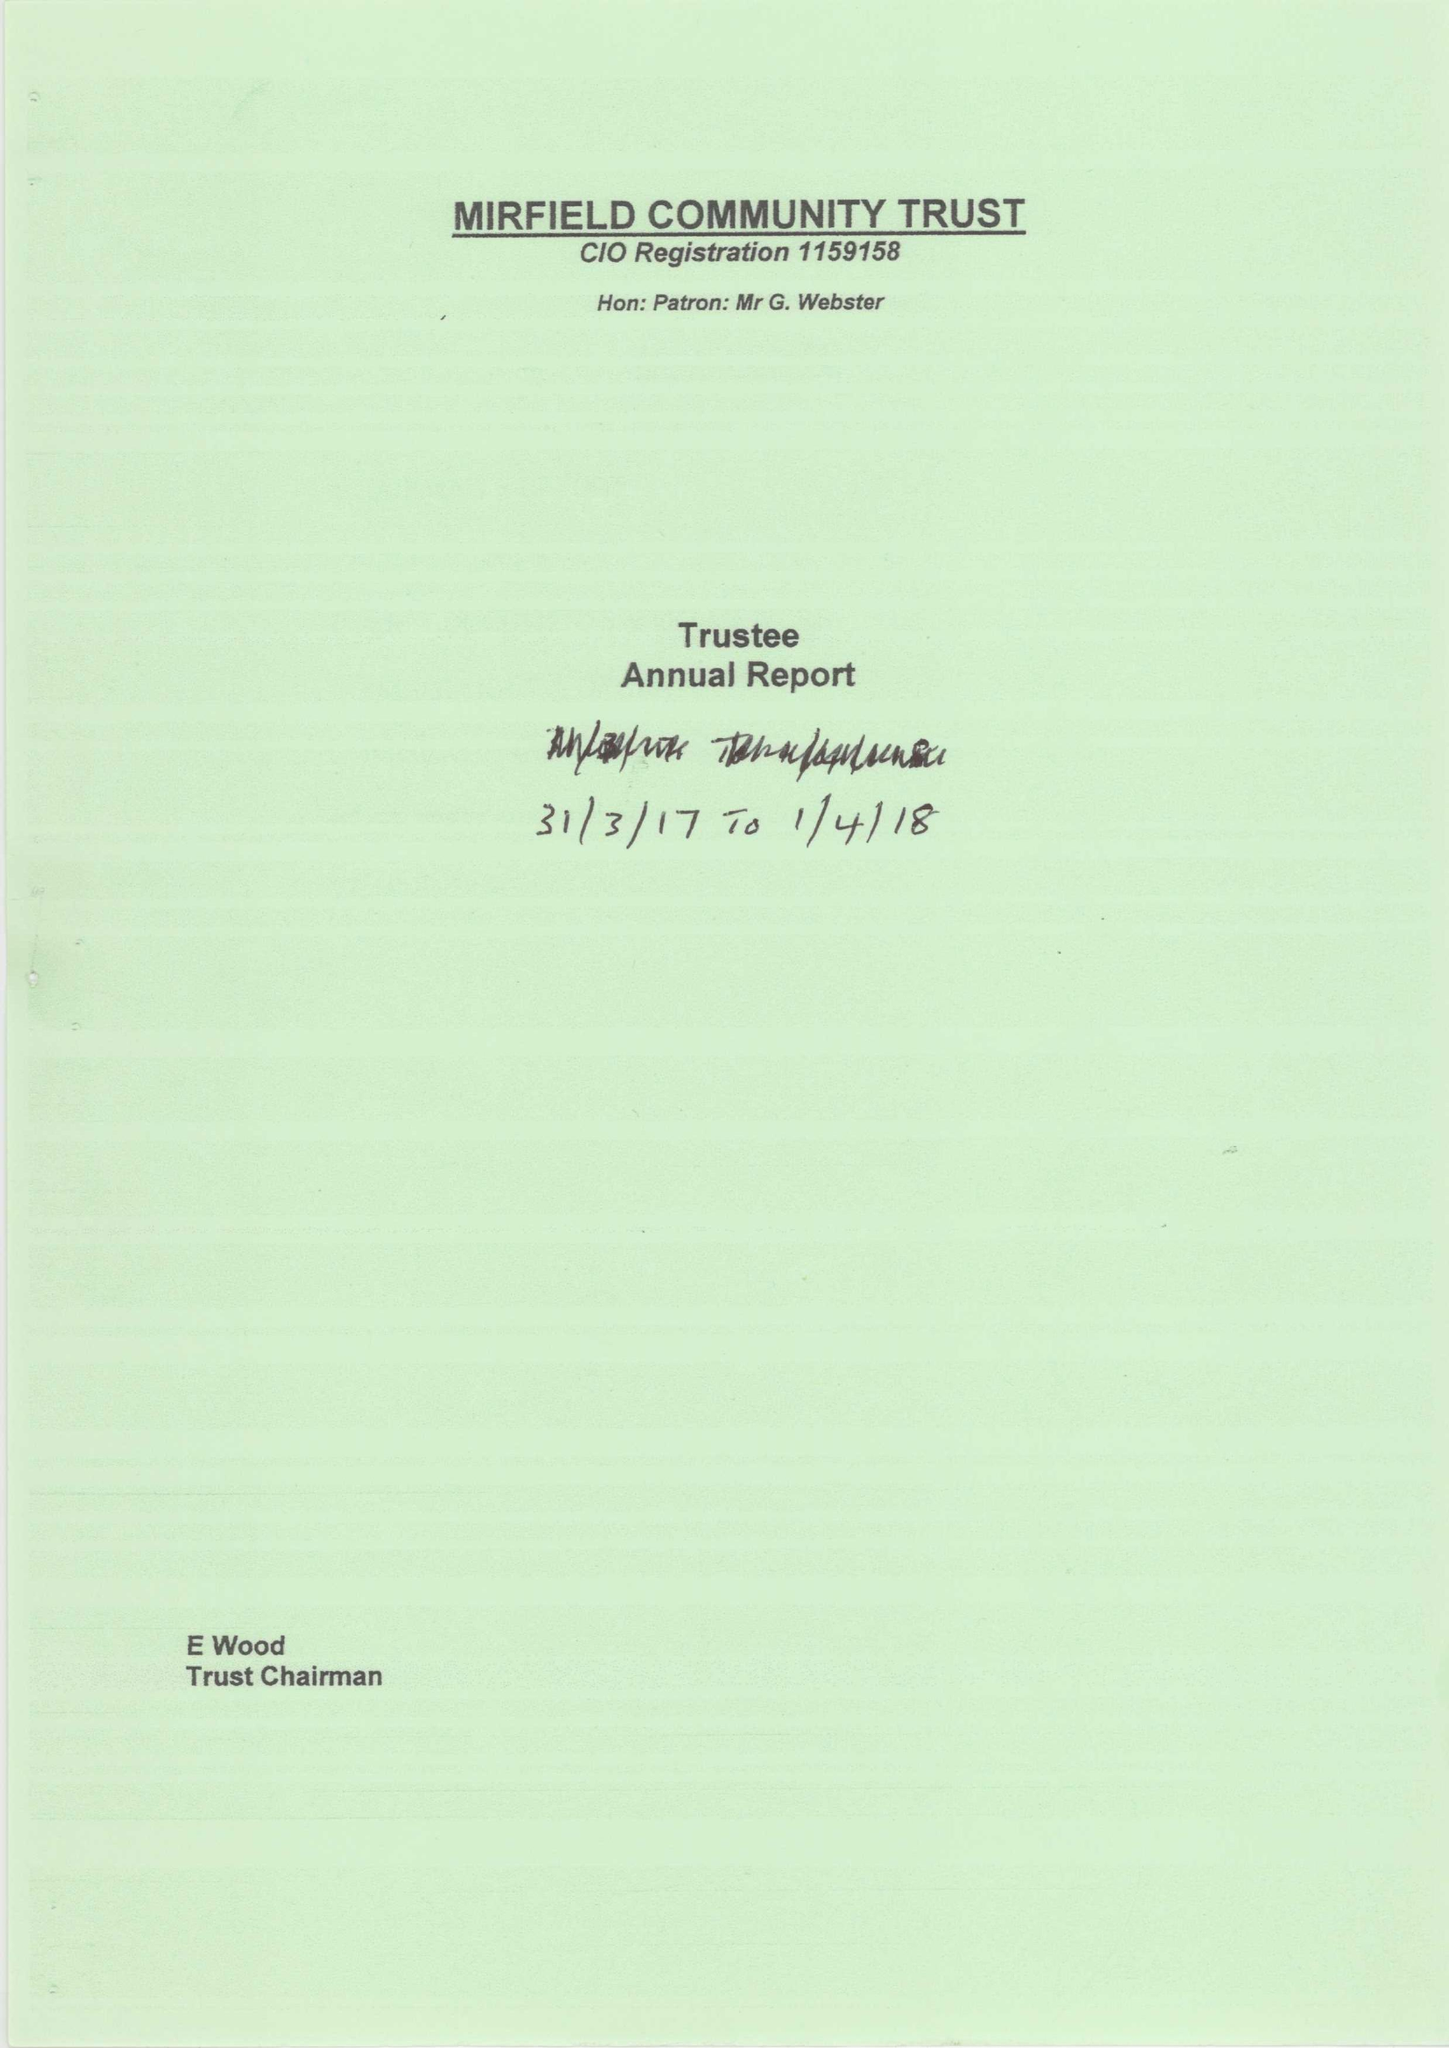What is the value for the address__postcode?
Answer the question using a single word or phrase. WF14 9JL 